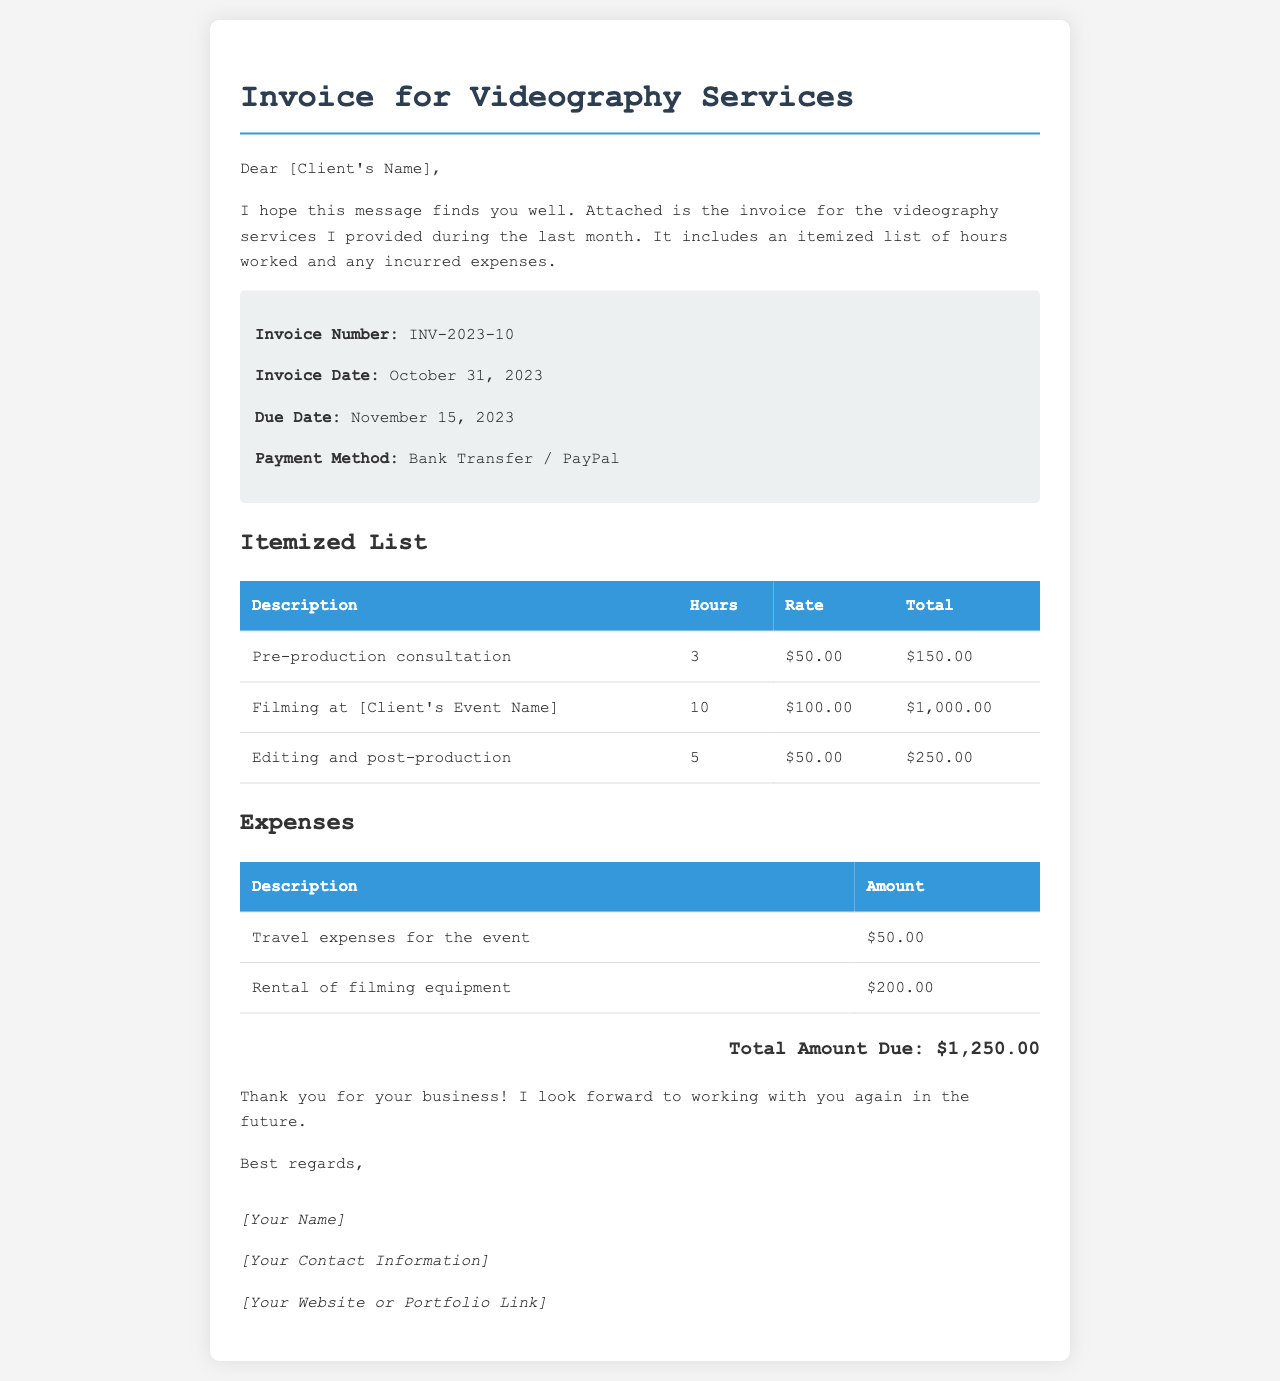What is the invoice number? The invoice number is listed in the invoice details section.
Answer: INV-2023-10 What is the total amount due? The total amount due is provided at the end of the invoice.
Answer: $1,250.00 What date is the invoice due? The due date can be found in the invoice details.
Answer: November 15, 2023 How many hours were spent on filming? The hours worked on filming are specified in the itemized list.
Answer: 10 What is the hourly rate for editing and post-production? The rate for editing and post-production can be found under the itemized list.
Answer: $50.00 What expense is associated with filming equipment? The expenses section lists the rental expense related to filming equipment.
Answer: $200.00 How many hours were allocated to pre-production consultation? The hours for pre-production consultation are detailed in the itemized list.
Answer: 3 What payment methods are accepted? The payment methods are mentioned in the invoice details section.
Answer: Bank Transfer / PayPal 